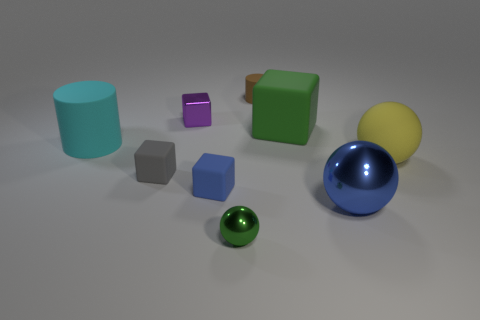Are there fewer tiny gray matte things that are behind the small rubber cylinder than blue cubes to the right of the green metallic sphere? Upon examining the image, it appears that the number of tiny gray matte objects positioned behind the small teal rubber cylinder is equivalent to the quantity of blue cubes situated to the right of the green metallic sphere, with each group consisting of one item. Therefore, the answer to your question is that there are not fewer tiny gray matte things behind the rubber cylinder compared to the blue cubes next to the sphere; there is an equal number of objects in each group. 